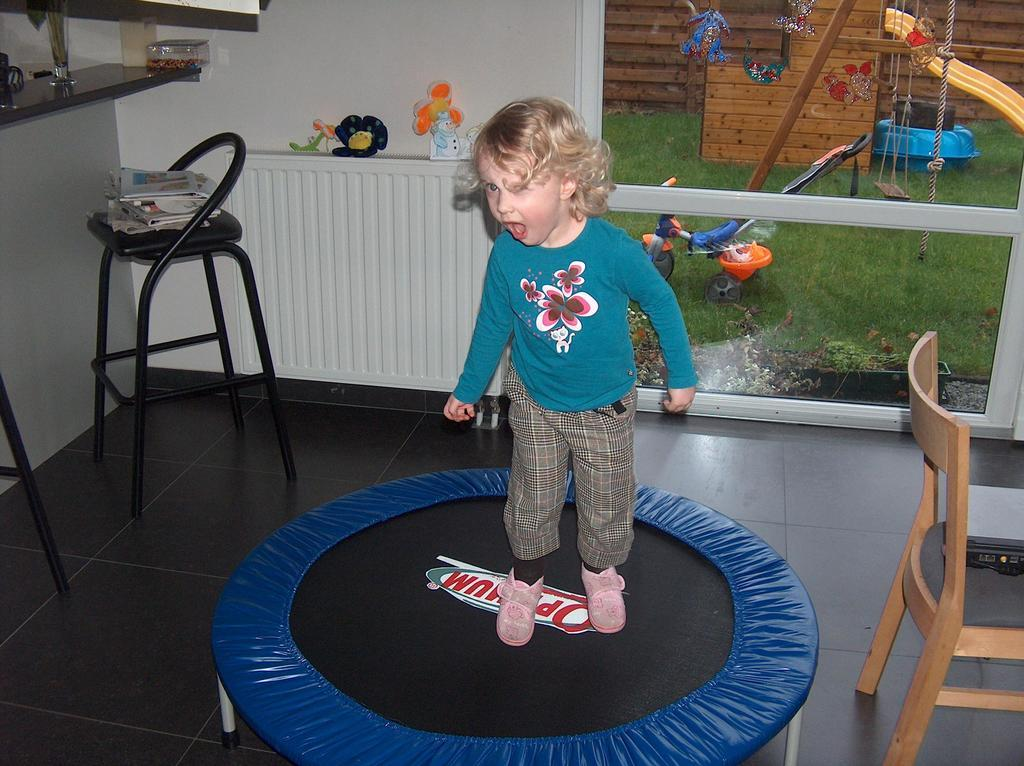Who is the main subject in the image? There is a girl in the image. What is the girl doing in the image? The girl is jumping on a trampoline. What can be seen in the background of the image? Chairs, a toy cycle, a rope, a swing, grass, a wall, and a cupboard with toys are visible in the background of the image. What other objects are present in the background of the image? There is also a rack in the background of the image. What type of clam can be seen on the girl's head in the image? There is no clam present in the image, and the girl is not wearing anything on her head. How many people are walking in the image? There is no person walking in the image; the girl is jumping on a trampoline. What type of cloud is visible in the image? There is no cloud visible in the image; the sky is not shown. 